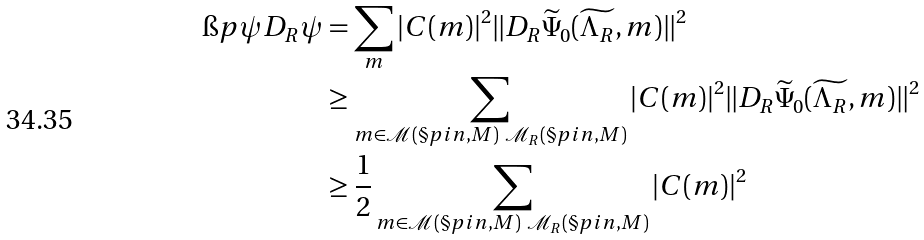Convert formula to latex. <formula><loc_0><loc_0><loc_500><loc_500>\i p { \psi } { D _ { R } \psi } & = \sum _ { m } | C ( m ) | ^ { 2 } \| D _ { R } \widetilde { \Psi } _ { 0 } ( \widetilde { \Lambda _ { R } } , m ) \| ^ { 2 } \\ & \geq \sum _ { m \in \mathcal { M } ( \S p i n , M ) \ \mathcal { M } _ { R } ( \S p i n , M ) } | C ( m ) | ^ { 2 } \| D _ { R } \widetilde { \Psi } _ { 0 } ( \widetilde { \Lambda _ { R } } , m ) \| ^ { 2 } \\ & \geq \frac { 1 } { 2 } \sum _ { m \in \mathcal { M } ( \S p i n , M ) \ \mathcal { M } _ { R } ( \S p i n , M ) } | C ( m ) | ^ { 2 }</formula> 